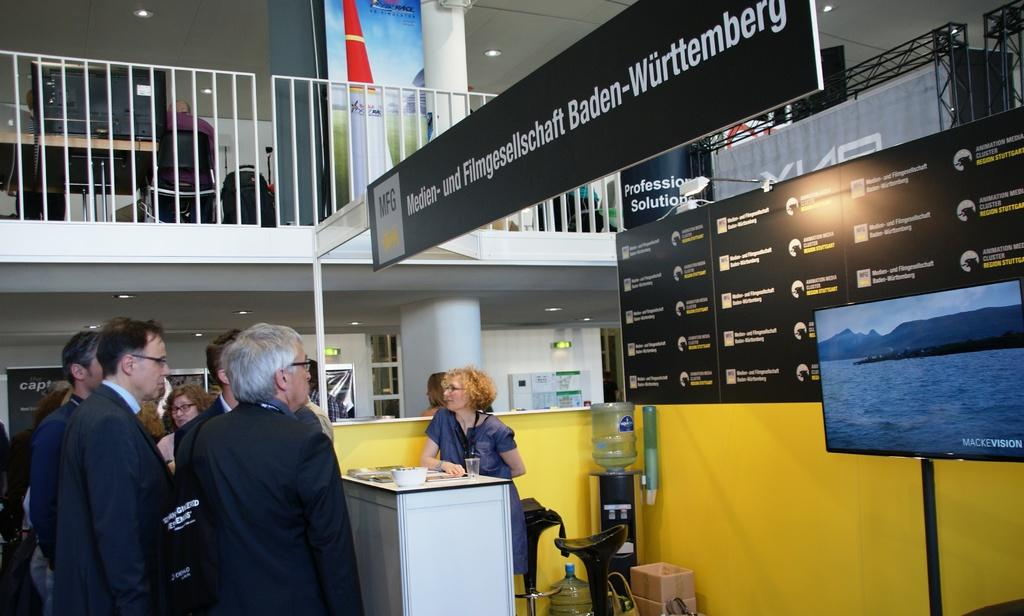<image>
Present a compact description of the photo's key features. A television behind a counter has the words Mackey Vision in the corner. 